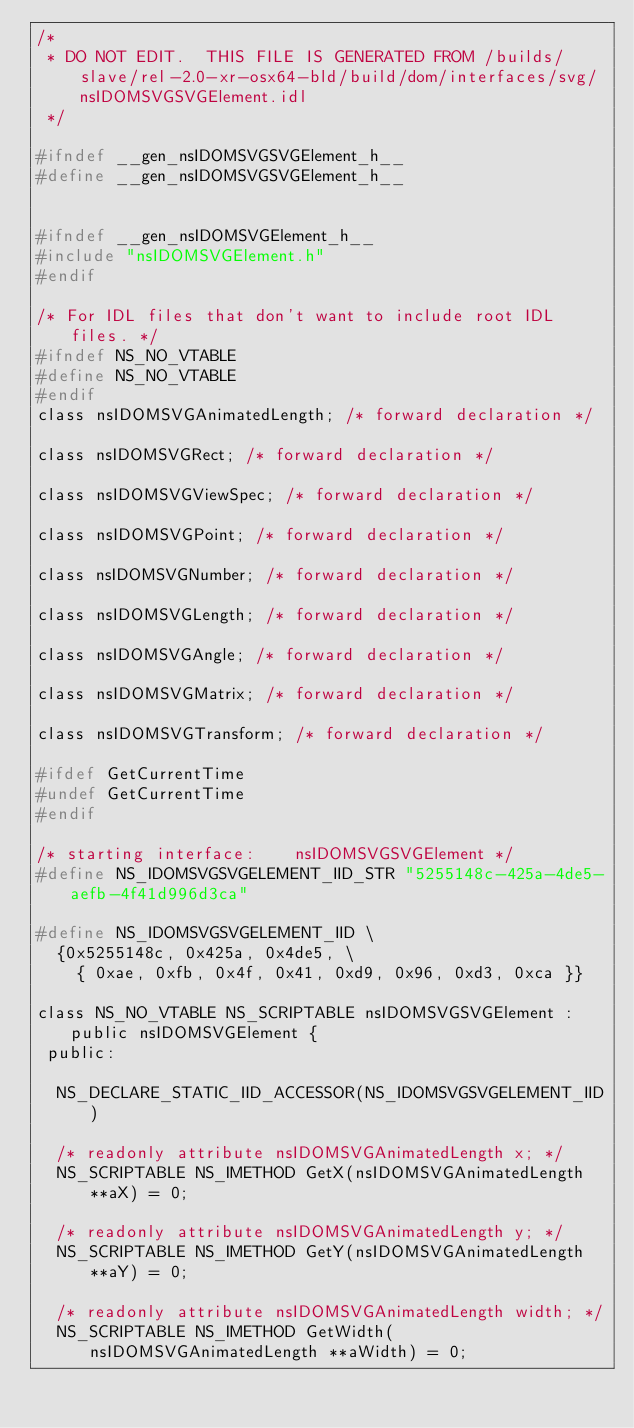<code> <loc_0><loc_0><loc_500><loc_500><_C_>/*
 * DO NOT EDIT.  THIS FILE IS GENERATED FROM /builds/slave/rel-2.0-xr-osx64-bld/build/dom/interfaces/svg/nsIDOMSVGSVGElement.idl
 */

#ifndef __gen_nsIDOMSVGSVGElement_h__
#define __gen_nsIDOMSVGSVGElement_h__


#ifndef __gen_nsIDOMSVGElement_h__
#include "nsIDOMSVGElement.h"
#endif

/* For IDL files that don't want to include root IDL files. */
#ifndef NS_NO_VTABLE
#define NS_NO_VTABLE
#endif
class nsIDOMSVGAnimatedLength; /* forward declaration */

class nsIDOMSVGRect; /* forward declaration */

class nsIDOMSVGViewSpec; /* forward declaration */

class nsIDOMSVGPoint; /* forward declaration */

class nsIDOMSVGNumber; /* forward declaration */

class nsIDOMSVGLength; /* forward declaration */

class nsIDOMSVGAngle; /* forward declaration */

class nsIDOMSVGMatrix; /* forward declaration */

class nsIDOMSVGTransform; /* forward declaration */

#ifdef GetCurrentTime
#undef GetCurrentTime
#endif

/* starting interface:    nsIDOMSVGSVGElement */
#define NS_IDOMSVGSVGELEMENT_IID_STR "5255148c-425a-4de5-aefb-4f41d996d3ca"

#define NS_IDOMSVGSVGELEMENT_IID \
  {0x5255148c, 0x425a, 0x4de5, \
    { 0xae, 0xfb, 0x4f, 0x41, 0xd9, 0x96, 0xd3, 0xca }}

class NS_NO_VTABLE NS_SCRIPTABLE nsIDOMSVGSVGElement : public nsIDOMSVGElement {
 public: 

  NS_DECLARE_STATIC_IID_ACCESSOR(NS_IDOMSVGSVGELEMENT_IID)

  /* readonly attribute nsIDOMSVGAnimatedLength x; */
  NS_SCRIPTABLE NS_IMETHOD GetX(nsIDOMSVGAnimatedLength **aX) = 0;

  /* readonly attribute nsIDOMSVGAnimatedLength y; */
  NS_SCRIPTABLE NS_IMETHOD GetY(nsIDOMSVGAnimatedLength **aY) = 0;

  /* readonly attribute nsIDOMSVGAnimatedLength width; */
  NS_SCRIPTABLE NS_IMETHOD GetWidth(nsIDOMSVGAnimatedLength **aWidth) = 0;
</code> 